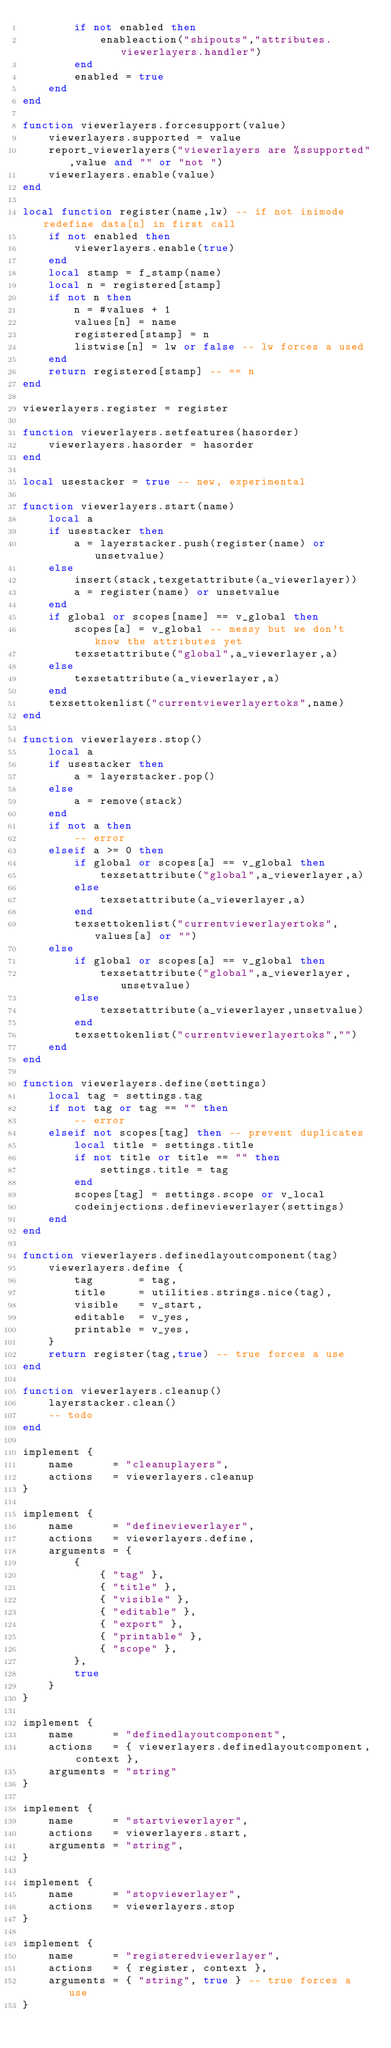<code> <loc_0><loc_0><loc_500><loc_500><_Lua_>        if not enabled then
            enableaction("shipouts","attributes.viewerlayers.handler")
        end
        enabled = true
    end
end

function viewerlayers.forcesupport(value)
    viewerlayers.supported = value
    report_viewerlayers("viewerlayers are %ssupported",value and "" or "not ")
    viewerlayers.enable(value)
end

local function register(name,lw) -- if not inimode redefine data[n] in first call
    if not enabled then
        viewerlayers.enable(true)
    end
    local stamp = f_stamp(name)
    local n = registered[stamp]
    if not n then
        n = #values + 1
        values[n] = name
        registered[stamp] = n
        listwise[n] = lw or false -- lw forces a used
    end
    return registered[stamp] -- == n
end

viewerlayers.register = register

function viewerlayers.setfeatures(hasorder)
    viewerlayers.hasorder = hasorder
end

local usestacker = true -- new, experimental

function viewerlayers.start(name)
    local a
    if usestacker then
        a = layerstacker.push(register(name) or unsetvalue)
    else
        insert(stack,texgetattribute(a_viewerlayer))
        a = register(name) or unsetvalue
    end
    if global or scopes[name] == v_global then
        scopes[a] = v_global -- messy but we don't know the attributes yet
        texsetattribute("global",a_viewerlayer,a)
    else
        texsetattribute(a_viewerlayer,a)
    end
    texsettokenlist("currentviewerlayertoks",name)
end

function viewerlayers.stop()
    local a
    if usestacker then
        a = layerstacker.pop()
    else
        a = remove(stack)
    end
    if not a then
        -- error
    elseif a >= 0 then
        if global or scopes[a] == v_global then
            texsetattribute("global",a_viewerlayer,a)
        else
            texsetattribute(a_viewerlayer,a)
        end
        texsettokenlist("currentviewerlayertoks",values[a] or "")
    else
        if global or scopes[a] == v_global then
            texsetattribute("global",a_viewerlayer,unsetvalue)
        else
            texsetattribute(a_viewerlayer,unsetvalue)
        end
        texsettokenlist("currentviewerlayertoks","")
    end
end

function viewerlayers.define(settings)
    local tag = settings.tag
    if not tag or tag == "" then
        -- error
    elseif not scopes[tag] then -- prevent duplicates
        local title = settings.title
        if not title or title == "" then
            settings.title = tag
        end
        scopes[tag] = settings.scope or v_local
        codeinjections.defineviewerlayer(settings)
    end
end

function viewerlayers.definedlayoutcomponent(tag)
    viewerlayers.define {
        tag       = tag,
        title     = utilities.strings.nice(tag),
        visible   = v_start,
        editable  = v_yes,
        printable = v_yes,
    }
    return register(tag,true) -- true forces a use
end

function viewerlayers.cleanup()
    layerstacker.clean()
    -- todo
end

implement {
    name      = "cleanuplayers",
    actions   = viewerlayers.cleanup
}

implement {
    name      = "defineviewerlayer",
    actions   = viewerlayers.define,
    arguments = {
        {
            { "tag" },
            { "title" },
            { "visible" },
            { "editable" },
            { "export" },
            { "printable" },
            { "scope" },
        },
        true
    }
}

implement {
    name      = "definedlayoutcomponent",
    actions   = { viewerlayers.definedlayoutcomponent, context },
    arguments = "string"
}

implement {
    name      = "startviewerlayer",
    actions   = viewerlayers.start,
    arguments = "string",
}

implement {
    name      = "stopviewerlayer",
    actions   = viewerlayers.stop
}

implement {
    name      = "registeredviewerlayer",
    actions   = { register, context },
    arguments = { "string", true } -- true forces a use
}
</code> 